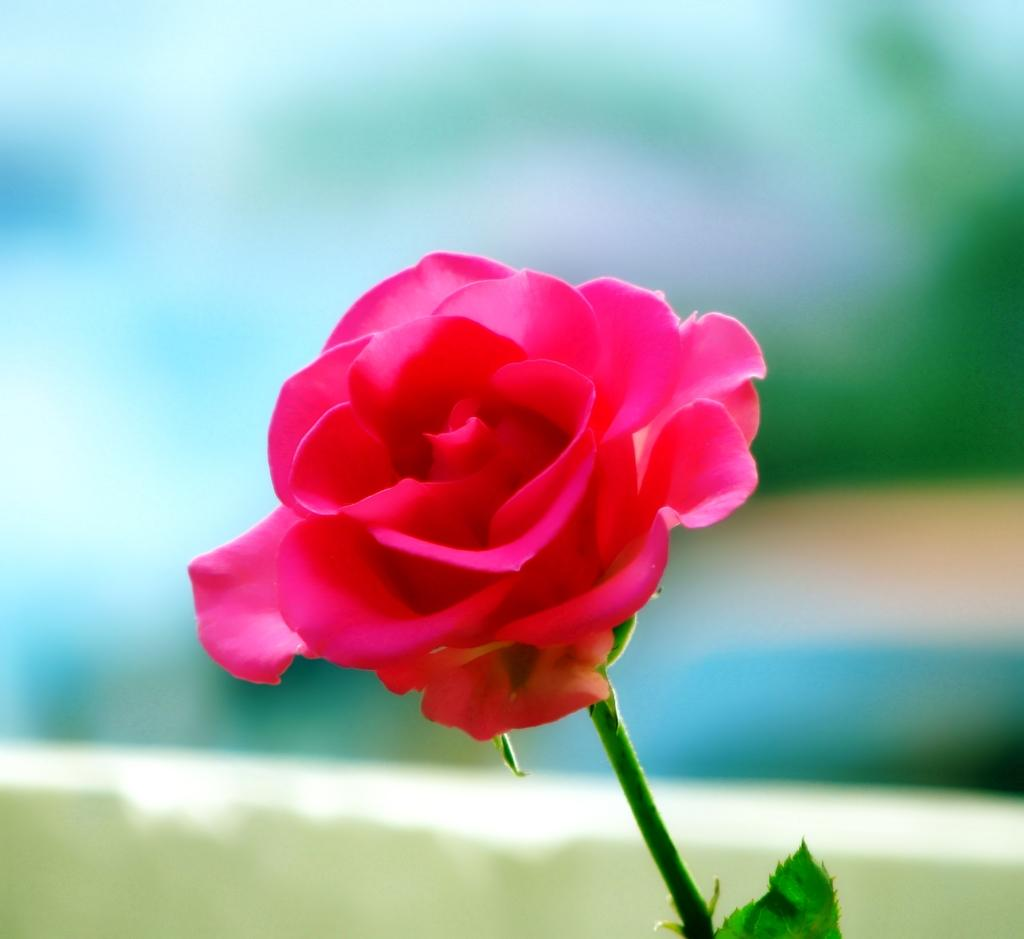What is the main subject of the image? There is a rose in the image. Where is the rose located in the image? The rose is in the center of the image. What color is the rose? The rose is pink in color. What type of flag is visible in the image? There is no flag present in the image; it features a pink rose in the center. How does the hair of the rose look like in the image? Roses do not have hair, so this detail cannot be observed in the image. 